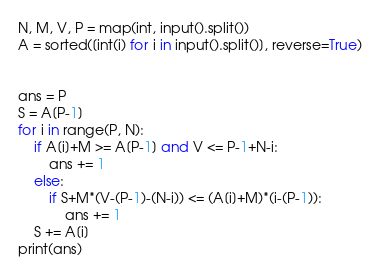<code> <loc_0><loc_0><loc_500><loc_500><_Python_>N, M, V, P = map(int, input().split())
A = sorted([int(i) for i in input().split()], reverse=True)


ans = P
S = A[P-1]
for i in range(P, N):
    if A[i]+M >= A[P-1] and V <= P-1+N-i:
        ans += 1
    else:
        if S+M*(V-(P-1)-(N-i)) <= (A[i]+M)*(i-(P-1)):
            ans += 1
    S += A[i]
print(ans)
</code> 